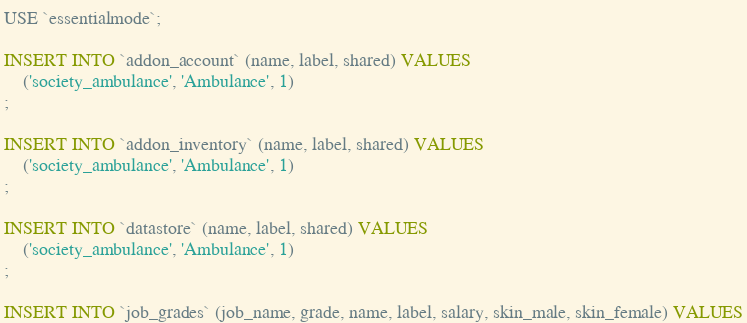Convert code to text. <code><loc_0><loc_0><loc_500><loc_500><_SQL_>USE `essentialmode`;

INSERT INTO `addon_account` (name, label, shared) VALUES
	('society_ambulance', 'Ambulance', 1)
;

INSERT INTO `addon_inventory` (name, label, shared) VALUES
	('society_ambulance', 'Ambulance', 1)
;

INSERT INTO `datastore` (name, label, shared) VALUES
	('society_ambulance', 'Ambulance', 1)
;

INSERT INTO `job_grades` (job_name, grade, name, label, salary, skin_male, skin_female) VALUES</code> 